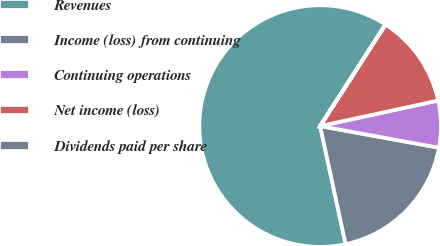Convert chart. <chart><loc_0><loc_0><loc_500><loc_500><pie_chart><fcel>Revenues<fcel>Income (loss) from continuing<fcel>Continuing operations<fcel>Net income (loss)<fcel>Dividends paid per share<nl><fcel>62.48%<fcel>18.75%<fcel>6.26%<fcel>12.5%<fcel>0.01%<nl></chart> 